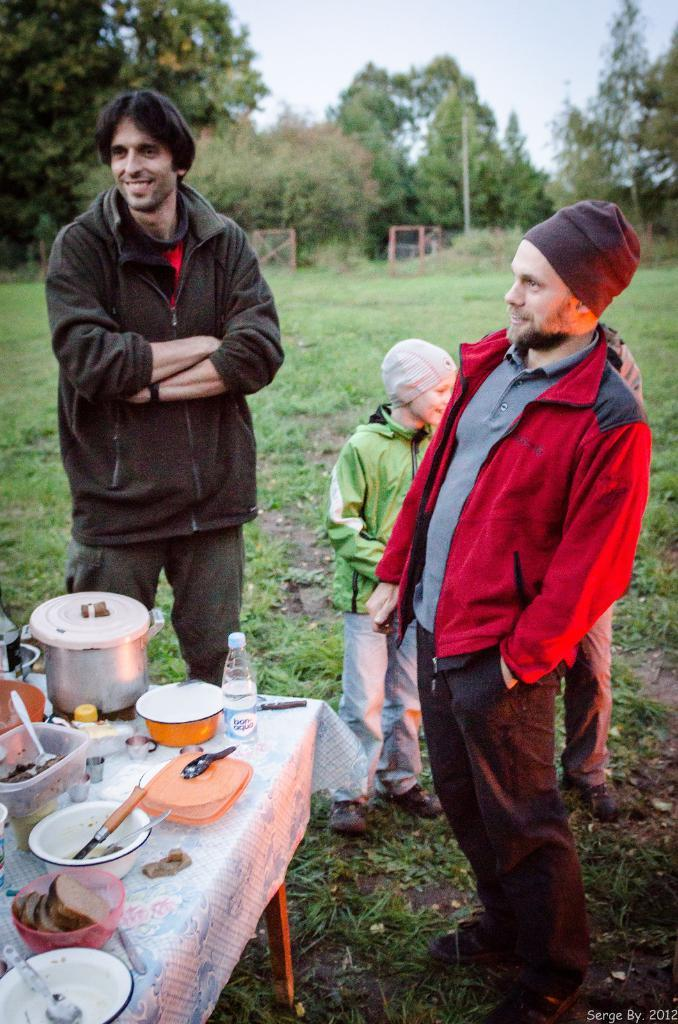What can be seen in the sky in the image? There is a sky in the image, but no specific details are provided about its appearance. What type of vegetation is present in the image? There are trees and grass in the image. How many people are standing in the image? There are three people standing in the image. What is on the table in the image? There is a cooker, a bowl, spoons, a box, and a bottle on the table in the image. Can you see a mitten being used to comb the paste in the image? There is no mitten, comb, or paste present in the image. 